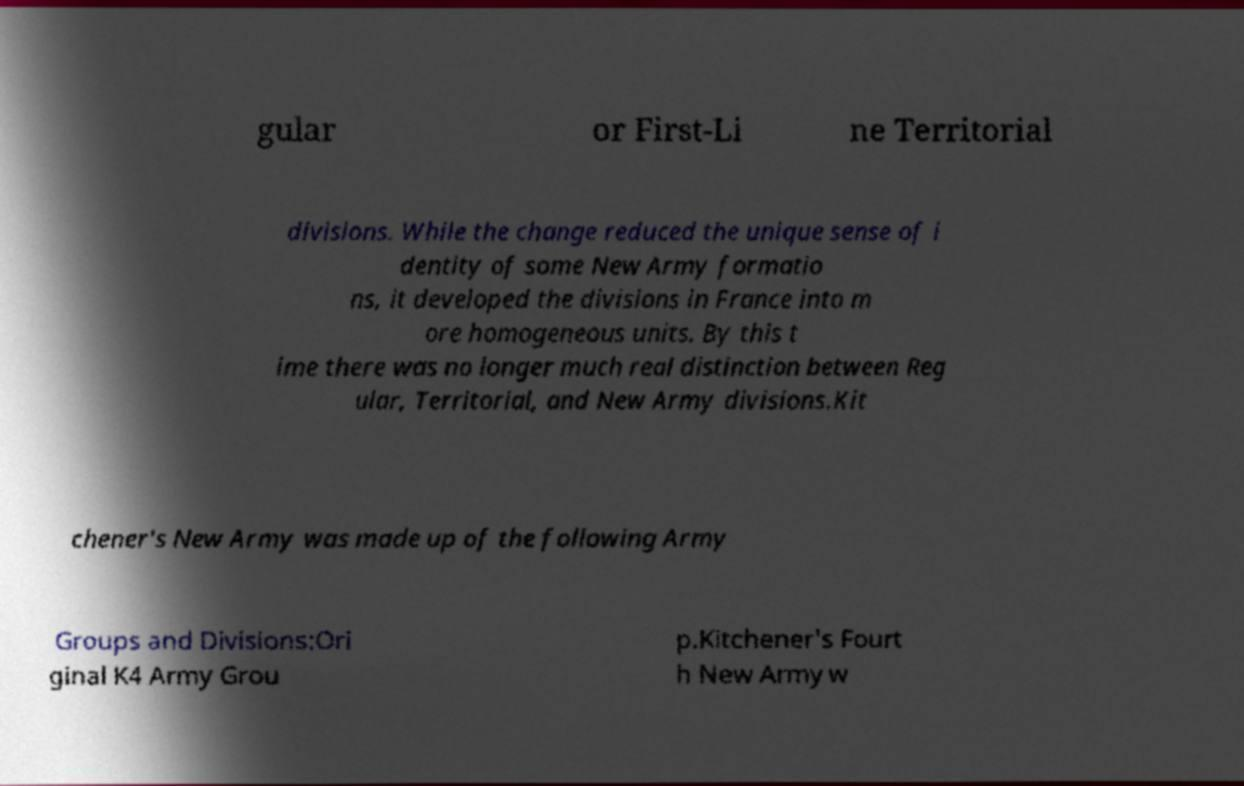Could you extract and type out the text from this image? gular or First-Li ne Territorial divisions. While the change reduced the unique sense of i dentity of some New Army formatio ns, it developed the divisions in France into m ore homogeneous units. By this t ime there was no longer much real distinction between Reg ular, Territorial, and New Army divisions.Kit chener's New Army was made up of the following Army Groups and Divisions:Ori ginal K4 Army Grou p.Kitchener's Fourt h New Army w 